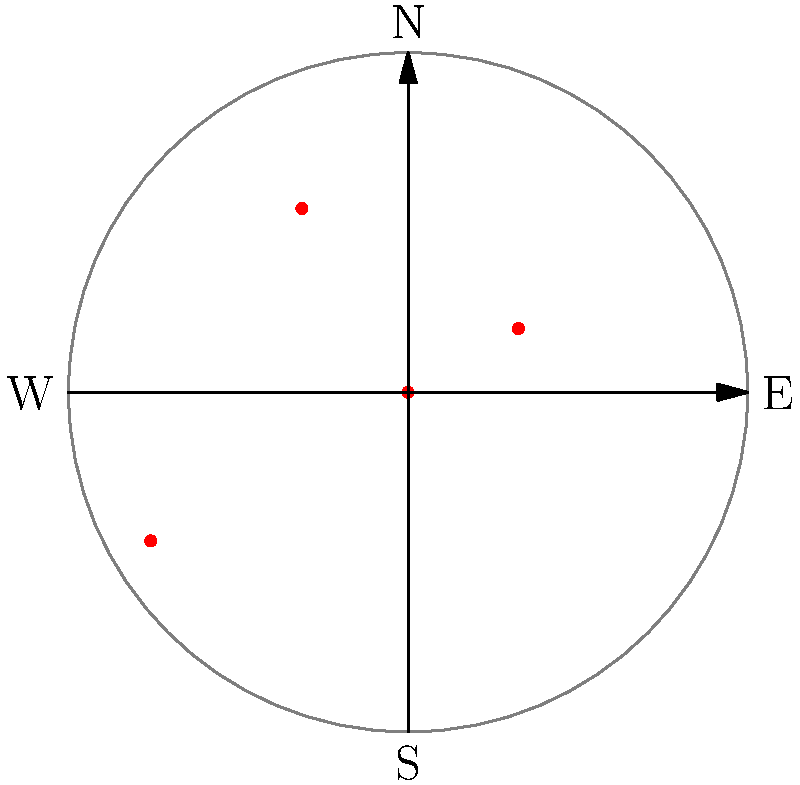As a naval observer during World War II, you've been tasked with tracking American ships using polar coordinates. The diagram shows the positions of four ships, with the origin representing your observation post. The concentric circle has a radius of 8 nautical miles. What is the range and direction of the ship farthest from your position? Express the direction in degrees measured clockwise from due North. To solve this problem, we need to follow these steps:

1. Identify the ship farthest from the origin (observation post).
2. Determine its polar coordinates (r, θ).
3. Convert the angle to degrees measured clockwise from due North.

Step 1: Looking at the diagram, we can see that the farthest point from the origin is at (7, 210°).

Step 2: The polar coordinates are already given as (r, θ) = (7, 210°).

Step 3: The angle is already measured clockwise from due North, so no conversion is needed.

Therefore, the range of the ship is 7 nautical miles, and its direction is 210° clockwise from due North.
Answer: 7 nautical miles, 210° 